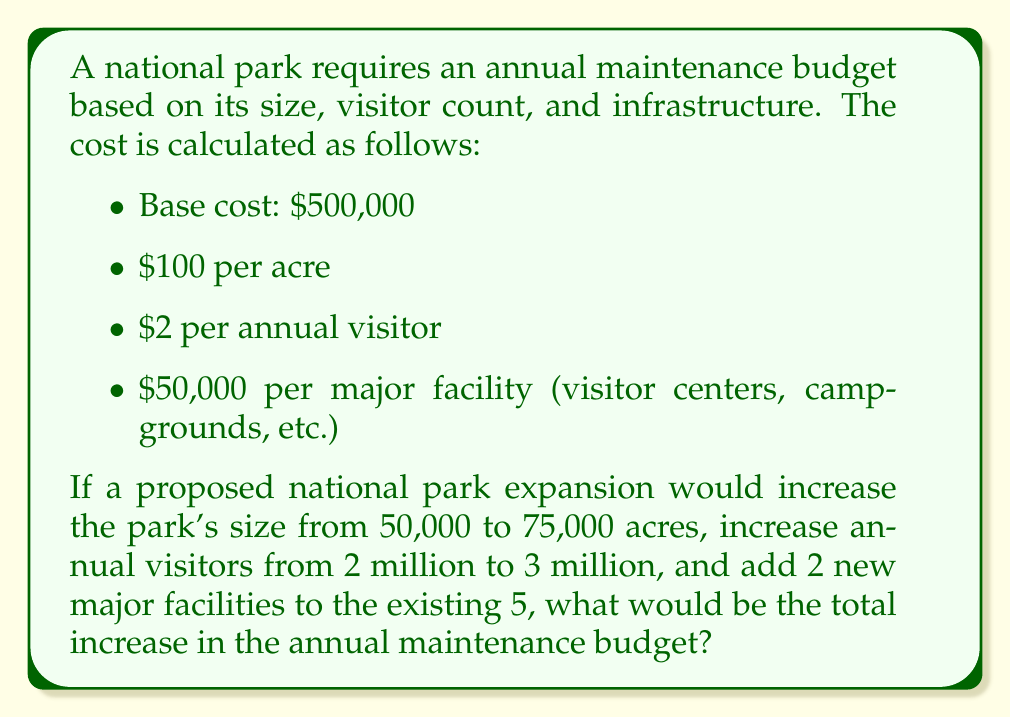Provide a solution to this math problem. Let's calculate the maintenance budget before and after the expansion, then find the difference:

1. Before expansion:
   Base cost: $500,000
   Acreage cost: $100 × 50,000 = $5,000,000
   Visitor cost: $2 × 2,000,000 = $4,000,000
   Facility cost: $50,000 × 5 = $250,000
   Total before: $500,000 + $5,000,000 + $4,000,000 + $250,000 = $9,750,000

2. After expansion:
   Base cost: $500,000 (unchanged)
   Acreage cost: $100 × 75,000 = $7,500,000
   Visitor cost: $2 × 3,000,000 = $6,000,000
   Facility cost: $50,000 × 7 = $350,000
   Total after: $500,000 + $7,500,000 + $6,000,000 + $350,000 = $14,350,000

3. Increase in budget:
   $14,350,000 - $9,750,000 = $4,600,000

Therefore, the total increase in the annual maintenance budget would be $4,600,000.
Answer: $4,600,000 